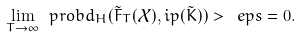<formula> <loc_0><loc_0><loc_500><loc_500>\lim _ { T \to \infty } \ p r o b { d _ { H } ( \tilde { F } _ { T } ( \mathcal { X } ) , \L i p ( \tilde { K } ) ) > \ e p s } = 0 .</formula> 